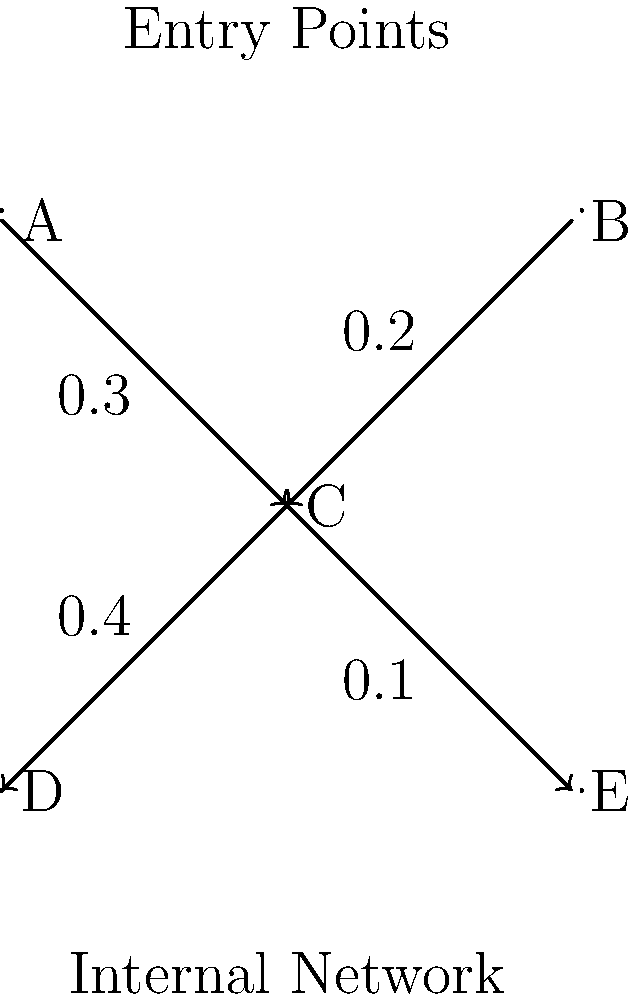Given the network topology shown in the diagram, where A and B represent external entry points, C represents an intermediate server, and D and E represent internal network segments, calculate the probability of a successful network intrusion reaching the internal network (either D or E). Assume that the probabilities of successful attacks are independent and are represented by the weights on the edges. To solve this problem, we need to calculate the probability of an attacker successfully reaching either D or E. We'll break this down step-by-step:

1) First, let's calculate the probability of reaching C from either A or B:
   
   $P(\text{reaching C}) = 1 - (1 - 0.3)(1 - 0.2) = 0.44$

2) Now, given that an attacker has reached C, we need to calculate the probability of reaching either D or E:
   
   $P(\text{reaching D or E | reached C}) = 1 - (1 - 0.4)(1 - 0.1) = 0.46$

3) The overall probability of a successful intrusion is the product of these two probabilities:

   $P(\text{successful intrusion}) = P(\text{reaching C}) \times P(\text{reaching D or E | reached C})$
   
   $= 0.44 \times 0.46 = 0.2024$

Therefore, the probability of a successful network intrusion reaching the internal network is approximately 0.2024 or 20.24%.
Answer: $0.2024$ or $20.24\%$ 